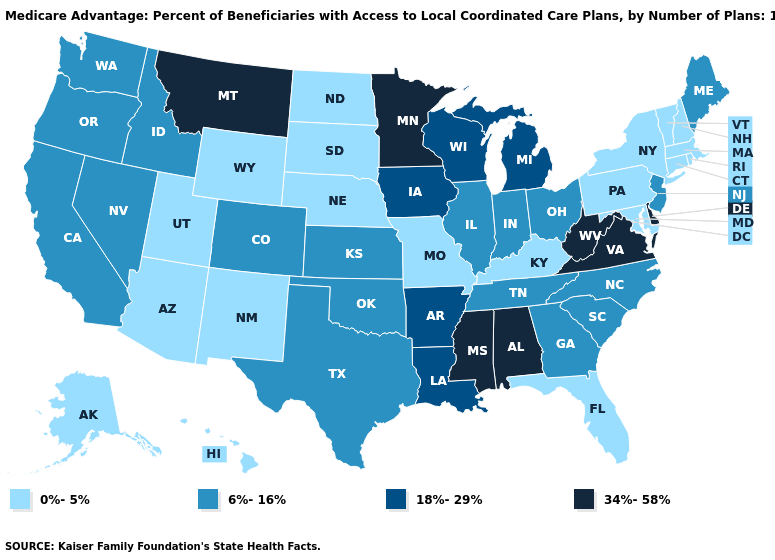What is the value of Illinois?
Write a very short answer. 6%-16%. Does Minnesota have a lower value than Utah?
Concise answer only. No. What is the highest value in the USA?
Keep it brief. 34%-58%. Name the states that have a value in the range 6%-16%?
Keep it brief. California, Colorado, Georgia, Idaho, Illinois, Indiana, Kansas, Maine, North Carolina, New Jersey, Nevada, Ohio, Oklahoma, Oregon, South Carolina, Tennessee, Texas, Washington. Is the legend a continuous bar?
Keep it brief. No. Does Iowa have the same value as New York?
Give a very brief answer. No. Which states have the lowest value in the MidWest?
Give a very brief answer. Missouri, North Dakota, Nebraska, South Dakota. What is the value of Hawaii?
Give a very brief answer. 0%-5%. What is the lowest value in the USA?
Give a very brief answer. 0%-5%. What is the value of New Mexico?
Answer briefly. 0%-5%. What is the lowest value in states that border North Carolina?
Give a very brief answer. 6%-16%. Name the states that have a value in the range 0%-5%?
Concise answer only. Alaska, Arizona, Connecticut, Florida, Hawaii, Kentucky, Massachusetts, Maryland, Missouri, North Dakota, Nebraska, New Hampshire, New Mexico, New York, Pennsylvania, Rhode Island, South Dakota, Utah, Vermont, Wyoming. Name the states that have a value in the range 6%-16%?
Answer briefly. California, Colorado, Georgia, Idaho, Illinois, Indiana, Kansas, Maine, North Carolina, New Jersey, Nevada, Ohio, Oklahoma, Oregon, South Carolina, Tennessee, Texas, Washington. What is the highest value in the Northeast ?
Write a very short answer. 6%-16%. Does the first symbol in the legend represent the smallest category?
Quick response, please. Yes. 